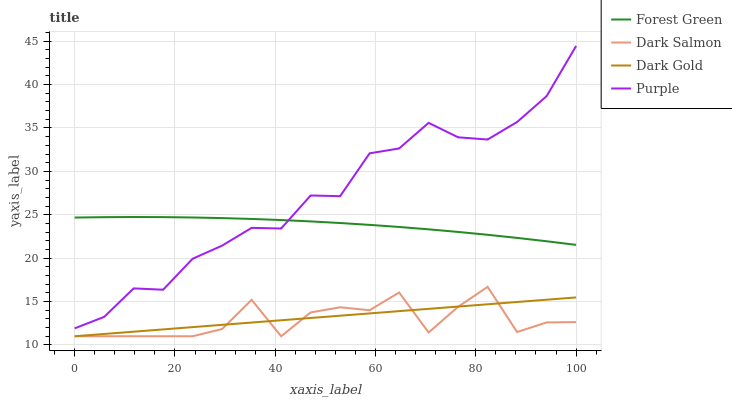Does Dark Salmon have the minimum area under the curve?
Answer yes or no. Yes. Does Purple have the maximum area under the curve?
Answer yes or no. Yes. Does Forest Green have the minimum area under the curve?
Answer yes or no. No. Does Forest Green have the maximum area under the curve?
Answer yes or no. No. Is Dark Gold the smoothest?
Answer yes or no. Yes. Is Dark Salmon the roughest?
Answer yes or no. Yes. Is Forest Green the smoothest?
Answer yes or no. No. Is Forest Green the roughest?
Answer yes or no. No. Does Forest Green have the lowest value?
Answer yes or no. No. Does Purple have the highest value?
Answer yes or no. Yes. Does Forest Green have the highest value?
Answer yes or no. No. Is Dark Gold less than Forest Green?
Answer yes or no. Yes. Is Purple greater than Dark Salmon?
Answer yes or no. Yes. Does Dark Gold intersect Dark Salmon?
Answer yes or no. Yes. Is Dark Gold less than Dark Salmon?
Answer yes or no. No. Is Dark Gold greater than Dark Salmon?
Answer yes or no. No. Does Dark Gold intersect Forest Green?
Answer yes or no. No. 